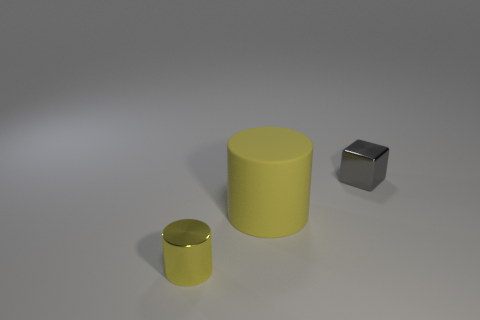There is a metallic thing to the right of the small yellow object; what color is it?
Make the answer very short. Gray. What is the shape of the large yellow object?
Offer a very short reply. Cylinder. What is the material of the yellow thing that is behind the shiny thing on the left side of the gray block?
Ensure brevity in your answer.  Rubber. How many other things are made of the same material as the tiny gray cube?
Your answer should be compact. 1. There is a yellow cylinder that is the same size as the block; what material is it?
Provide a succinct answer. Metal. Is the number of objects behind the tiny yellow shiny cylinder greater than the number of tiny gray metal cubes in front of the large thing?
Make the answer very short. Yes. Is there another small yellow metal object of the same shape as the small yellow metal object?
Make the answer very short. No. The other metal thing that is the same size as the gray metallic object is what shape?
Keep it short and to the point. Cylinder. There is a metallic thing that is in front of the small block; what is its shape?
Make the answer very short. Cylinder. Is the number of yellow cylinders that are left of the small yellow shiny thing less than the number of cubes that are on the left side of the yellow matte thing?
Provide a short and direct response. No. 